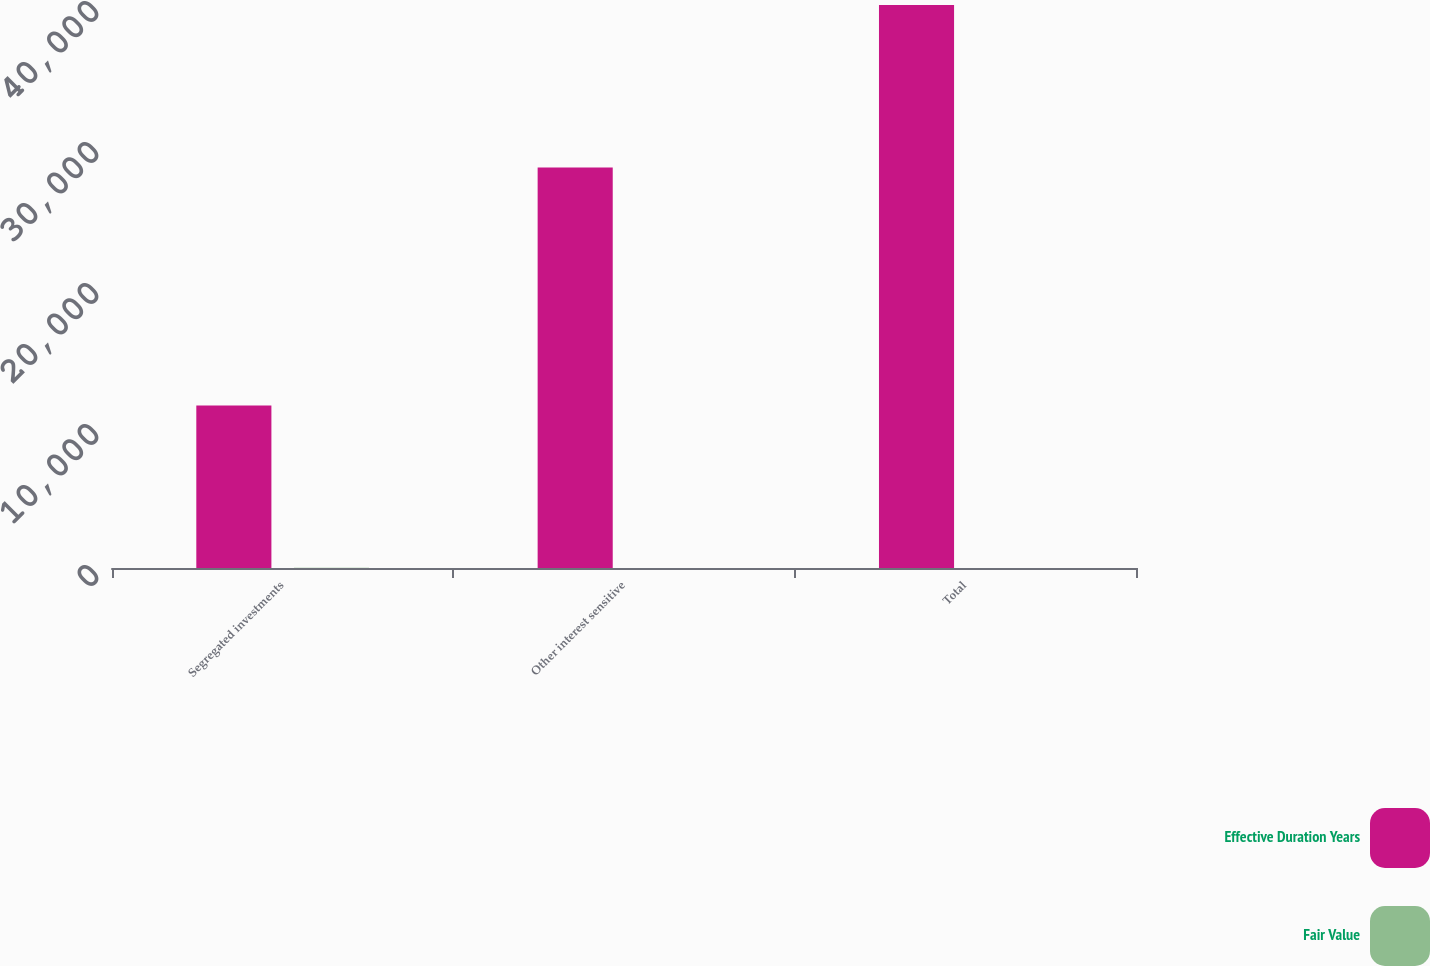<chart> <loc_0><loc_0><loc_500><loc_500><stacked_bar_chart><ecel><fcel>Segregated investments<fcel>Other interest sensitive<fcel>Total<nl><fcel>Effective Duration Years<fcel>11516<fcel>28405<fcel>39921<nl><fcel>Fair Value<fcel>10.9<fcel>4.6<fcel>6.4<nl></chart> 